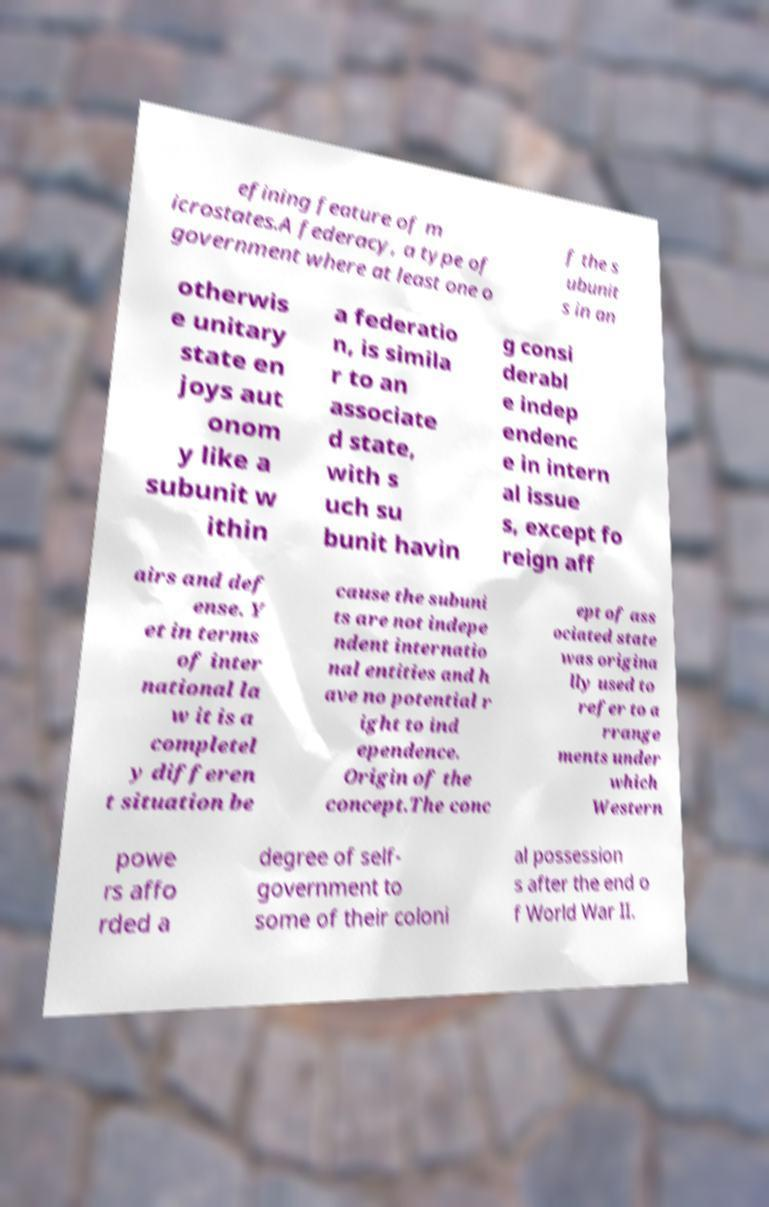I need the written content from this picture converted into text. Can you do that? efining feature of m icrostates.A federacy, a type of government where at least one o f the s ubunit s in an otherwis e unitary state en joys aut onom y like a subunit w ithin a federatio n, is simila r to an associate d state, with s uch su bunit havin g consi derabl e indep endenc e in intern al issue s, except fo reign aff airs and def ense. Y et in terms of inter national la w it is a completel y differen t situation be cause the subuni ts are not indepe ndent internatio nal entities and h ave no potential r ight to ind ependence. Origin of the concept.The conc ept of ass ociated state was origina lly used to refer to a rrange ments under which Western powe rs affo rded a degree of self- government to some of their coloni al possession s after the end o f World War II. 